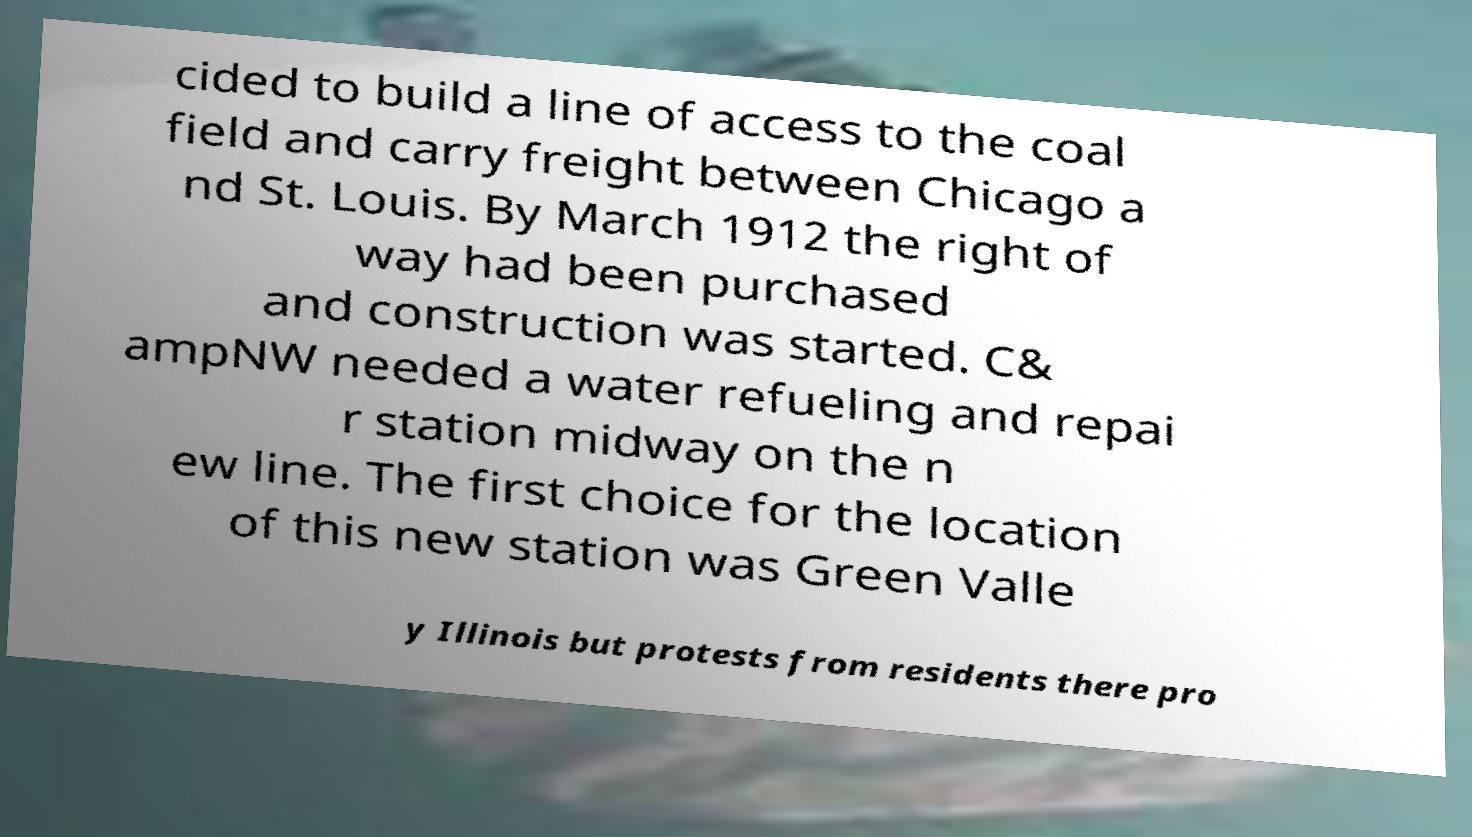There's text embedded in this image that I need extracted. Can you transcribe it verbatim? cided to build a line of access to the coal field and carry freight between Chicago a nd St. Louis. By March 1912 the right of way had been purchased and construction was started. C& ampNW needed a water refueling and repai r station midway on the n ew line. The first choice for the location of this new station was Green Valle y Illinois but protests from residents there pro 